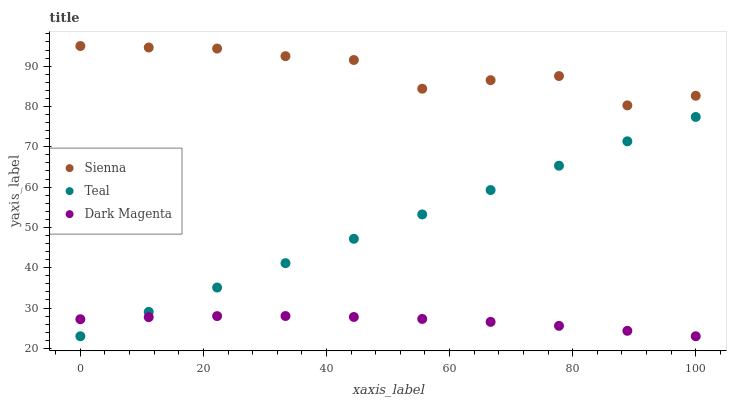Does Dark Magenta have the minimum area under the curve?
Answer yes or no. Yes. Does Sienna have the maximum area under the curve?
Answer yes or no. Yes. Does Teal have the minimum area under the curve?
Answer yes or no. No. Does Teal have the maximum area under the curve?
Answer yes or no. No. Is Teal the smoothest?
Answer yes or no. Yes. Is Sienna the roughest?
Answer yes or no. Yes. Is Dark Magenta the smoothest?
Answer yes or no. No. Is Dark Magenta the roughest?
Answer yes or no. No. Does Dark Magenta have the lowest value?
Answer yes or no. Yes. Does Sienna have the highest value?
Answer yes or no. Yes. Does Teal have the highest value?
Answer yes or no. No. Is Teal less than Sienna?
Answer yes or no. Yes. Is Sienna greater than Teal?
Answer yes or no. Yes. Does Dark Magenta intersect Teal?
Answer yes or no. Yes. Is Dark Magenta less than Teal?
Answer yes or no. No. Is Dark Magenta greater than Teal?
Answer yes or no. No. Does Teal intersect Sienna?
Answer yes or no. No. 